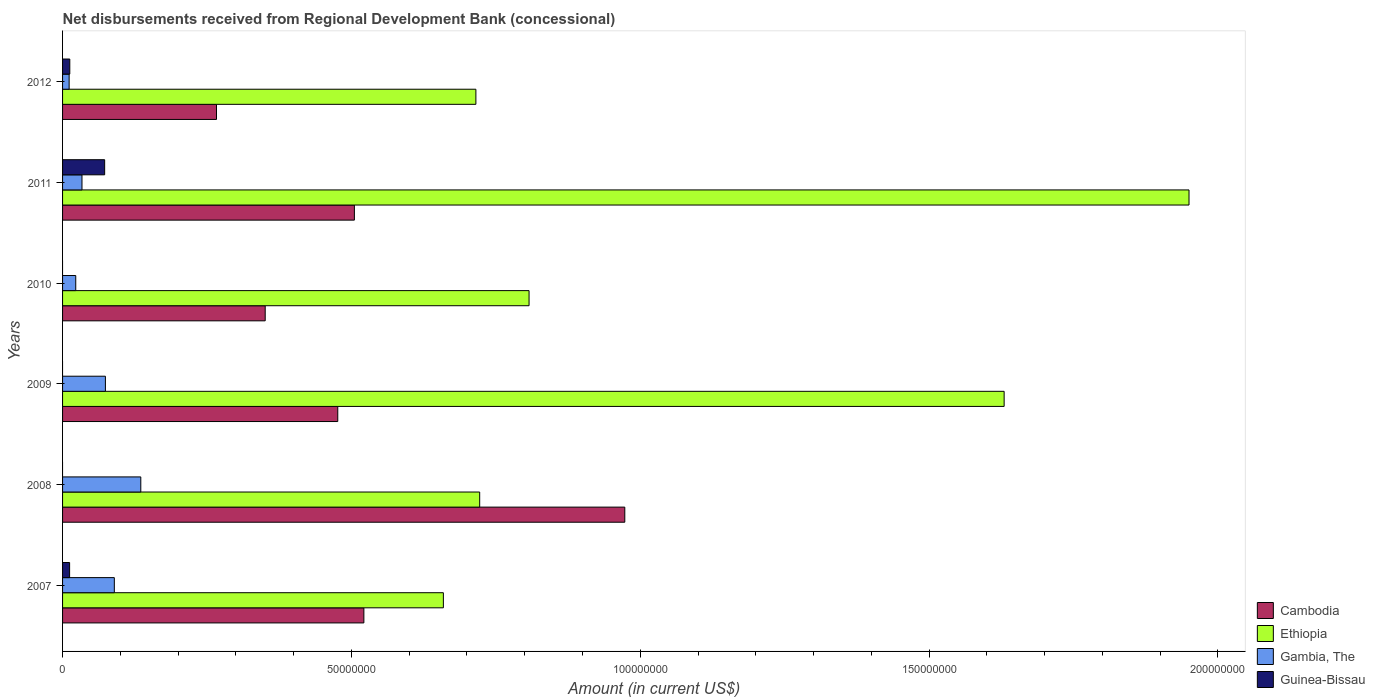Are the number of bars per tick equal to the number of legend labels?
Offer a very short reply. No. Are the number of bars on each tick of the Y-axis equal?
Ensure brevity in your answer.  No. In how many cases, is the number of bars for a given year not equal to the number of legend labels?
Your response must be concise. 3. What is the amount of disbursements received from Regional Development Bank in Ethiopia in 2007?
Your answer should be very brief. 6.59e+07. Across all years, what is the maximum amount of disbursements received from Regional Development Bank in Guinea-Bissau?
Make the answer very short. 7.28e+06. Across all years, what is the minimum amount of disbursements received from Regional Development Bank in Cambodia?
Make the answer very short. 2.66e+07. What is the total amount of disbursements received from Regional Development Bank in Gambia, The in the graph?
Your answer should be very brief. 3.67e+07. What is the difference between the amount of disbursements received from Regional Development Bank in Cambodia in 2007 and that in 2012?
Make the answer very short. 2.55e+07. What is the difference between the amount of disbursements received from Regional Development Bank in Guinea-Bissau in 2011 and the amount of disbursements received from Regional Development Bank in Cambodia in 2012?
Offer a terse response. -1.94e+07. What is the average amount of disbursements received from Regional Development Bank in Gambia, The per year?
Ensure brevity in your answer.  6.12e+06. In the year 2007, what is the difference between the amount of disbursements received from Regional Development Bank in Cambodia and amount of disbursements received from Regional Development Bank in Ethiopia?
Offer a terse response. -1.38e+07. In how many years, is the amount of disbursements received from Regional Development Bank in Ethiopia greater than 90000000 US$?
Provide a short and direct response. 2. What is the ratio of the amount of disbursements received from Regional Development Bank in Ethiopia in 2008 to that in 2010?
Ensure brevity in your answer.  0.89. Is the amount of disbursements received from Regional Development Bank in Ethiopia in 2007 less than that in 2011?
Provide a short and direct response. Yes. Is the difference between the amount of disbursements received from Regional Development Bank in Cambodia in 2007 and 2009 greater than the difference between the amount of disbursements received from Regional Development Bank in Ethiopia in 2007 and 2009?
Offer a terse response. Yes. What is the difference between the highest and the second highest amount of disbursements received from Regional Development Bank in Cambodia?
Your answer should be very brief. 4.52e+07. What is the difference between the highest and the lowest amount of disbursements received from Regional Development Bank in Ethiopia?
Make the answer very short. 1.29e+08. In how many years, is the amount of disbursements received from Regional Development Bank in Cambodia greater than the average amount of disbursements received from Regional Development Bank in Cambodia taken over all years?
Provide a succinct answer. 2. Is it the case that in every year, the sum of the amount of disbursements received from Regional Development Bank in Guinea-Bissau and amount of disbursements received from Regional Development Bank in Gambia, The is greater than the sum of amount of disbursements received from Regional Development Bank in Ethiopia and amount of disbursements received from Regional Development Bank in Cambodia?
Provide a short and direct response. No. Is it the case that in every year, the sum of the amount of disbursements received from Regional Development Bank in Gambia, The and amount of disbursements received from Regional Development Bank in Ethiopia is greater than the amount of disbursements received from Regional Development Bank in Guinea-Bissau?
Provide a succinct answer. Yes. How many bars are there?
Your answer should be very brief. 21. Are all the bars in the graph horizontal?
Your answer should be very brief. Yes. What is the difference between two consecutive major ticks on the X-axis?
Your answer should be very brief. 5.00e+07. How many legend labels are there?
Keep it short and to the point. 4. What is the title of the graph?
Your answer should be very brief. Net disbursements received from Regional Development Bank (concessional). Does "St. Martin (French part)" appear as one of the legend labels in the graph?
Offer a terse response. No. What is the Amount (in current US$) of Cambodia in 2007?
Ensure brevity in your answer.  5.22e+07. What is the Amount (in current US$) in Ethiopia in 2007?
Provide a short and direct response. 6.59e+07. What is the Amount (in current US$) in Gambia, The in 2007?
Provide a short and direct response. 8.96e+06. What is the Amount (in current US$) in Guinea-Bissau in 2007?
Provide a succinct answer. 1.22e+06. What is the Amount (in current US$) of Cambodia in 2008?
Provide a succinct answer. 9.73e+07. What is the Amount (in current US$) of Ethiopia in 2008?
Your response must be concise. 7.22e+07. What is the Amount (in current US$) in Gambia, The in 2008?
Offer a terse response. 1.35e+07. What is the Amount (in current US$) of Cambodia in 2009?
Make the answer very short. 4.76e+07. What is the Amount (in current US$) in Ethiopia in 2009?
Give a very brief answer. 1.63e+08. What is the Amount (in current US$) in Gambia, The in 2009?
Make the answer very short. 7.42e+06. What is the Amount (in current US$) of Cambodia in 2010?
Provide a succinct answer. 3.51e+07. What is the Amount (in current US$) in Ethiopia in 2010?
Give a very brief answer. 8.08e+07. What is the Amount (in current US$) in Gambia, The in 2010?
Your answer should be compact. 2.28e+06. What is the Amount (in current US$) of Cambodia in 2011?
Offer a very short reply. 5.05e+07. What is the Amount (in current US$) of Ethiopia in 2011?
Your answer should be very brief. 1.95e+08. What is the Amount (in current US$) of Gambia, The in 2011?
Give a very brief answer. 3.36e+06. What is the Amount (in current US$) of Guinea-Bissau in 2011?
Give a very brief answer. 7.28e+06. What is the Amount (in current US$) of Cambodia in 2012?
Offer a very short reply. 2.66e+07. What is the Amount (in current US$) of Ethiopia in 2012?
Ensure brevity in your answer.  7.15e+07. What is the Amount (in current US$) of Gambia, The in 2012?
Offer a very short reply. 1.14e+06. What is the Amount (in current US$) of Guinea-Bissau in 2012?
Ensure brevity in your answer.  1.25e+06. Across all years, what is the maximum Amount (in current US$) in Cambodia?
Your answer should be very brief. 9.73e+07. Across all years, what is the maximum Amount (in current US$) in Ethiopia?
Provide a short and direct response. 1.95e+08. Across all years, what is the maximum Amount (in current US$) of Gambia, The?
Provide a short and direct response. 1.35e+07. Across all years, what is the maximum Amount (in current US$) in Guinea-Bissau?
Your response must be concise. 7.28e+06. Across all years, what is the minimum Amount (in current US$) of Cambodia?
Ensure brevity in your answer.  2.66e+07. Across all years, what is the minimum Amount (in current US$) of Ethiopia?
Your response must be concise. 6.59e+07. Across all years, what is the minimum Amount (in current US$) of Gambia, The?
Give a very brief answer. 1.14e+06. What is the total Amount (in current US$) in Cambodia in the graph?
Your answer should be compact. 3.09e+08. What is the total Amount (in current US$) of Ethiopia in the graph?
Make the answer very short. 6.48e+08. What is the total Amount (in current US$) in Gambia, The in the graph?
Your answer should be very brief. 3.67e+07. What is the total Amount (in current US$) in Guinea-Bissau in the graph?
Offer a terse response. 9.76e+06. What is the difference between the Amount (in current US$) in Cambodia in 2007 and that in 2008?
Your answer should be very brief. -4.52e+07. What is the difference between the Amount (in current US$) in Ethiopia in 2007 and that in 2008?
Ensure brevity in your answer.  -6.29e+06. What is the difference between the Amount (in current US$) of Gambia, The in 2007 and that in 2008?
Give a very brief answer. -4.58e+06. What is the difference between the Amount (in current US$) of Cambodia in 2007 and that in 2009?
Your answer should be very brief. 4.52e+06. What is the difference between the Amount (in current US$) in Ethiopia in 2007 and that in 2009?
Your response must be concise. -9.71e+07. What is the difference between the Amount (in current US$) of Gambia, The in 2007 and that in 2009?
Offer a terse response. 1.55e+06. What is the difference between the Amount (in current US$) in Cambodia in 2007 and that in 2010?
Your response must be concise. 1.71e+07. What is the difference between the Amount (in current US$) in Ethiopia in 2007 and that in 2010?
Your answer should be very brief. -1.48e+07. What is the difference between the Amount (in current US$) in Gambia, The in 2007 and that in 2010?
Ensure brevity in your answer.  6.68e+06. What is the difference between the Amount (in current US$) in Cambodia in 2007 and that in 2011?
Offer a very short reply. 1.64e+06. What is the difference between the Amount (in current US$) in Ethiopia in 2007 and that in 2011?
Make the answer very short. -1.29e+08. What is the difference between the Amount (in current US$) in Gambia, The in 2007 and that in 2011?
Your response must be concise. 5.60e+06. What is the difference between the Amount (in current US$) of Guinea-Bissau in 2007 and that in 2011?
Give a very brief answer. -6.06e+06. What is the difference between the Amount (in current US$) of Cambodia in 2007 and that in 2012?
Your answer should be very brief. 2.55e+07. What is the difference between the Amount (in current US$) in Ethiopia in 2007 and that in 2012?
Make the answer very short. -5.63e+06. What is the difference between the Amount (in current US$) of Gambia, The in 2007 and that in 2012?
Your response must be concise. 7.82e+06. What is the difference between the Amount (in current US$) of Guinea-Bissau in 2007 and that in 2012?
Your answer should be very brief. -3.20e+04. What is the difference between the Amount (in current US$) in Cambodia in 2008 and that in 2009?
Ensure brevity in your answer.  4.97e+07. What is the difference between the Amount (in current US$) in Ethiopia in 2008 and that in 2009?
Give a very brief answer. -9.08e+07. What is the difference between the Amount (in current US$) in Gambia, The in 2008 and that in 2009?
Your response must be concise. 6.13e+06. What is the difference between the Amount (in current US$) in Cambodia in 2008 and that in 2010?
Your response must be concise. 6.22e+07. What is the difference between the Amount (in current US$) in Ethiopia in 2008 and that in 2010?
Your answer should be very brief. -8.55e+06. What is the difference between the Amount (in current US$) in Gambia, The in 2008 and that in 2010?
Keep it short and to the point. 1.13e+07. What is the difference between the Amount (in current US$) of Cambodia in 2008 and that in 2011?
Provide a succinct answer. 4.68e+07. What is the difference between the Amount (in current US$) in Ethiopia in 2008 and that in 2011?
Offer a terse response. -1.23e+08. What is the difference between the Amount (in current US$) in Gambia, The in 2008 and that in 2011?
Your answer should be very brief. 1.02e+07. What is the difference between the Amount (in current US$) of Cambodia in 2008 and that in 2012?
Your response must be concise. 7.07e+07. What is the difference between the Amount (in current US$) in Ethiopia in 2008 and that in 2012?
Your answer should be compact. 6.56e+05. What is the difference between the Amount (in current US$) in Gambia, The in 2008 and that in 2012?
Ensure brevity in your answer.  1.24e+07. What is the difference between the Amount (in current US$) in Cambodia in 2009 and that in 2010?
Offer a very short reply. 1.26e+07. What is the difference between the Amount (in current US$) in Ethiopia in 2009 and that in 2010?
Provide a succinct answer. 8.22e+07. What is the difference between the Amount (in current US$) of Gambia, The in 2009 and that in 2010?
Your response must be concise. 5.13e+06. What is the difference between the Amount (in current US$) of Cambodia in 2009 and that in 2011?
Give a very brief answer. -2.88e+06. What is the difference between the Amount (in current US$) of Ethiopia in 2009 and that in 2011?
Provide a succinct answer. -3.20e+07. What is the difference between the Amount (in current US$) of Gambia, The in 2009 and that in 2011?
Offer a terse response. 4.05e+06. What is the difference between the Amount (in current US$) in Cambodia in 2009 and that in 2012?
Offer a very short reply. 2.10e+07. What is the difference between the Amount (in current US$) of Ethiopia in 2009 and that in 2012?
Ensure brevity in your answer.  9.14e+07. What is the difference between the Amount (in current US$) of Gambia, The in 2009 and that in 2012?
Keep it short and to the point. 6.28e+06. What is the difference between the Amount (in current US$) of Cambodia in 2010 and that in 2011?
Make the answer very short. -1.54e+07. What is the difference between the Amount (in current US$) of Ethiopia in 2010 and that in 2011?
Make the answer very short. -1.14e+08. What is the difference between the Amount (in current US$) of Gambia, The in 2010 and that in 2011?
Your answer should be compact. -1.08e+06. What is the difference between the Amount (in current US$) in Cambodia in 2010 and that in 2012?
Provide a succinct answer. 8.43e+06. What is the difference between the Amount (in current US$) in Ethiopia in 2010 and that in 2012?
Ensure brevity in your answer.  9.20e+06. What is the difference between the Amount (in current US$) in Gambia, The in 2010 and that in 2012?
Make the answer very short. 1.15e+06. What is the difference between the Amount (in current US$) in Cambodia in 2011 and that in 2012?
Your response must be concise. 2.39e+07. What is the difference between the Amount (in current US$) of Ethiopia in 2011 and that in 2012?
Keep it short and to the point. 1.23e+08. What is the difference between the Amount (in current US$) of Gambia, The in 2011 and that in 2012?
Offer a very short reply. 2.22e+06. What is the difference between the Amount (in current US$) of Guinea-Bissau in 2011 and that in 2012?
Offer a very short reply. 6.03e+06. What is the difference between the Amount (in current US$) in Cambodia in 2007 and the Amount (in current US$) in Ethiopia in 2008?
Offer a terse response. -2.00e+07. What is the difference between the Amount (in current US$) in Cambodia in 2007 and the Amount (in current US$) in Gambia, The in 2008?
Offer a terse response. 3.86e+07. What is the difference between the Amount (in current US$) of Ethiopia in 2007 and the Amount (in current US$) of Gambia, The in 2008?
Offer a very short reply. 5.24e+07. What is the difference between the Amount (in current US$) in Cambodia in 2007 and the Amount (in current US$) in Ethiopia in 2009?
Offer a very short reply. -1.11e+08. What is the difference between the Amount (in current US$) of Cambodia in 2007 and the Amount (in current US$) of Gambia, The in 2009?
Ensure brevity in your answer.  4.47e+07. What is the difference between the Amount (in current US$) of Ethiopia in 2007 and the Amount (in current US$) of Gambia, The in 2009?
Ensure brevity in your answer.  5.85e+07. What is the difference between the Amount (in current US$) in Cambodia in 2007 and the Amount (in current US$) in Ethiopia in 2010?
Provide a succinct answer. -2.86e+07. What is the difference between the Amount (in current US$) in Cambodia in 2007 and the Amount (in current US$) in Gambia, The in 2010?
Provide a succinct answer. 4.99e+07. What is the difference between the Amount (in current US$) in Ethiopia in 2007 and the Amount (in current US$) in Gambia, The in 2010?
Keep it short and to the point. 6.36e+07. What is the difference between the Amount (in current US$) in Cambodia in 2007 and the Amount (in current US$) in Ethiopia in 2011?
Provide a succinct answer. -1.43e+08. What is the difference between the Amount (in current US$) of Cambodia in 2007 and the Amount (in current US$) of Gambia, The in 2011?
Make the answer very short. 4.88e+07. What is the difference between the Amount (in current US$) in Cambodia in 2007 and the Amount (in current US$) in Guinea-Bissau in 2011?
Offer a very short reply. 4.49e+07. What is the difference between the Amount (in current US$) in Ethiopia in 2007 and the Amount (in current US$) in Gambia, The in 2011?
Provide a short and direct response. 6.26e+07. What is the difference between the Amount (in current US$) of Ethiopia in 2007 and the Amount (in current US$) of Guinea-Bissau in 2011?
Provide a succinct answer. 5.86e+07. What is the difference between the Amount (in current US$) of Gambia, The in 2007 and the Amount (in current US$) of Guinea-Bissau in 2011?
Your response must be concise. 1.68e+06. What is the difference between the Amount (in current US$) in Cambodia in 2007 and the Amount (in current US$) in Ethiopia in 2012?
Your answer should be very brief. -1.94e+07. What is the difference between the Amount (in current US$) of Cambodia in 2007 and the Amount (in current US$) of Gambia, The in 2012?
Ensure brevity in your answer.  5.10e+07. What is the difference between the Amount (in current US$) in Cambodia in 2007 and the Amount (in current US$) in Guinea-Bissau in 2012?
Provide a succinct answer. 5.09e+07. What is the difference between the Amount (in current US$) of Ethiopia in 2007 and the Amount (in current US$) of Gambia, The in 2012?
Ensure brevity in your answer.  6.48e+07. What is the difference between the Amount (in current US$) of Ethiopia in 2007 and the Amount (in current US$) of Guinea-Bissau in 2012?
Your answer should be very brief. 6.47e+07. What is the difference between the Amount (in current US$) of Gambia, The in 2007 and the Amount (in current US$) of Guinea-Bissau in 2012?
Your answer should be compact. 7.71e+06. What is the difference between the Amount (in current US$) of Cambodia in 2008 and the Amount (in current US$) of Ethiopia in 2009?
Give a very brief answer. -6.57e+07. What is the difference between the Amount (in current US$) in Cambodia in 2008 and the Amount (in current US$) in Gambia, The in 2009?
Offer a very short reply. 8.99e+07. What is the difference between the Amount (in current US$) of Ethiopia in 2008 and the Amount (in current US$) of Gambia, The in 2009?
Your answer should be compact. 6.48e+07. What is the difference between the Amount (in current US$) of Cambodia in 2008 and the Amount (in current US$) of Ethiopia in 2010?
Ensure brevity in your answer.  1.66e+07. What is the difference between the Amount (in current US$) of Cambodia in 2008 and the Amount (in current US$) of Gambia, The in 2010?
Provide a succinct answer. 9.50e+07. What is the difference between the Amount (in current US$) in Ethiopia in 2008 and the Amount (in current US$) in Gambia, The in 2010?
Keep it short and to the point. 6.99e+07. What is the difference between the Amount (in current US$) in Cambodia in 2008 and the Amount (in current US$) in Ethiopia in 2011?
Your response must be concise. -9.77e+07. What is the difference between the Amount (in current US$) in Cambodia in 2008 and the Amount (in current US$) in Gambia, The in 2011?
Make the answer very short. 9.40e+07. What is the difference between the Amount (in current US$) in Cambodia in 2008 and the Amount (in current US$) in Guinea-Bissau in 2011?
Your answer should be compact. 9.00e+07. What is the difference between the Amount (in current US$) of Ethiopia in 2008 and the Amount (in current US$) of Gambia, The in 2011?
Provide a succinct answer. 6.88e+07. What is the difference between the Amount (in current US$) of Ethiopia in 2008 and the Amount (in current US$) of Guinea-Bissau in 2011?
Make the answer very short. 6.49e+07. What is the difference between the Amount (in current US$) in Gambia, The in 2008 and the Amount (in current US$) in Guinea-Bissau in 2011?
Your answer should be very brief. 6.26e+06. What is the difference between the Amount (in current US$) of Cambodia in 2008 and the Amount (in current US$) of Ethiopia in 2012?
Provide a succinct answer. 2.58e+07. What is the difference between the Amount (in current US$) in Cambodia in 2008 and the Amount (in current US$) in Gambia, The in 2012?
Provide a short and direct response. 9.62e+07. What is the difference between the Amount (in current US$) of Cambodia in 2008 and the Amount (in current US$) of Guinea-Bissau in 2012?
Keep it short and to the point. 9.61e+07. What is the difference between the Amount (in current US$) in Ethiopia in 2008 and the Amount (in current US$) in Gambia, The in 2012?
Provide a short and direct response. 7.11e+07. What is the difference between the Amount (in current US$) in Ethiopia in 2008 and the Amount (in current US$) in Guinea-Bissau in 2012?
Offer a very short reply. 7.10e+07. What is the difference between the Amount (in current US$) in Gambia, The in 2008 and the Amount (in current US$) in Guinea-Bissau in 2012?
Offer a very short reply. 1.23e+07. What is the difference between the Amount (in current US$) of Cambodia in 2009 and the Amount (in current US$) of Ethiopia in 2010?
Provide a short and direct response. -3.31e+07. What is the difference between the Amount (in current US$) of Cambodia in 2009 and the Amount (in current US$) of Gambia, The in 2010?
Give a very brief answer. 4.54e+07. What is the difference between the Amount (in current US$) of Ethiopia in 2009 and the Amount (in current US$) of Gambia, The in 2010?
Your answer should be compact. 1.61e+08. What is the difference between the Amount (in current US$) in Cambodia in 2009 and the Amount (in current US$) in Ethiopia in 2011?
Your answer should be very brief. -1.47e+08. What is the difference between the Amount (in current US$) in Cambodia in 2009 and the Amount (in current US$) in Gambia, The in 2011?
Ensure brevity in your answer.  4.43e+07. What is the difference between the Amount (in current US$) of Cambodia in 2009 and the Amount (in current US$) of Guinea-Bissau in 2011?
Make the answer very short. 4.04e+07. What is the difference between the Amount (in current US$) of Ethiopia in 2009 and the Amount (in current US$) of Gambia, The in 2011?
Give a very brief answer. 1.60e+08. What is the difference between the Amount (in current US$) of Ethiopia in 2009 and the Amount (in current US$) of Guinea-Bissau in 2011?
Give a very brief answer. 1.56e+08. What is the difference between the Amount (in current US$) of Gambia, The in 2009 and the Amount (in current US$) of Guinea-Bissau in 2011?
Your answer should be compact. 1.30e+05. What is the difference between the Amount (in current US$) in Cambodia in 2009 and the Amount (in current US$) in Ethiopia in 2012?
Make the answer very short. -2.39e+07. What is the difference between the Amount (in current US$) of Cambodia in 2009 and the Amount (in current US$) of Gambia, The in 2012?
Your response must be concise. 4.65e+07. What is the difference between the Amount (in current US$) in Cambodia in 2009 and the Amount (in current US$) in Guinea-Bissau in 2012?
Your response must be concise. 4.64e+07. What is the difference between the Amount (in current US$) of Ethiopia in 2009 and the Amount (in current US$) of Gambia, The in 2012?
Make the answer very short. 1.62e+08. What is the difference between the Amount (in current US$) in Ethiopia in 2009 and the Amount (in current US$) in Guinea-Bissau in 2012?
Your response must be concise. 1.62e+08. What is the difference between the Amount (in current US$) of Gambia, The in 2009 and the Amount (in current US$) of Guinea-Bissau in 2012?
Your answer should be compact. 6.16e+06. What is the difference between the Amount (in current US$) in Cambodia in 2010 and the Amount (in current US$) in Ethiopia in 2011?
Your answer should be compact. -1.60e+08. What is the difference between the Amount (in current US$) in Cambodia in 2010 and the Amount (in current US$) in Gambia, The in 2011?
Offer a terse response. 3.17e+07. What is the difference between the Amount (in current US$) in Cambodia in 2010 and the Amount (in current US$) in Guinea-Bissau in 2011?
Ensure brevity in your answer.  2.78e+07. What is the difference between the Amount (in current US$) of Ethiopia in 2010 and the Amount (in current US$) of Gambia, The in 2011?
Your response must be concise. 7.74e+07. What is the difference between the Amount (in current US$) of Ethiopia in 2010 and the Amount (in current US$) of Guinea-Bissau in 2011?
Your answer should be compact. 7.35e+07. What is the difference between the Amount (in current US$) of Gambia, The in 2010 and the Amount (in current US$) of Guinea-Bissau in 2011?
Make the answer very short. -5.00e+06. What is the difference between the Amount (in current US$) in Cambodia in 2010 and the Amount (in current US$) in Ethiopia in 2012?
Offer a terse response. -3.65e+07. What is the difference between the Amount (in current US$) of Cambodia in 2010 and the Amount (in current US$) of Gambia, The in 2012?
Ensure brevity in your answer.  3.39e+07. What is the difference between the Amount (in current US$) of Cambodia in 2010 and the Amount (in current US$) of Guinea-Bissau in 2012?
Offer a terse response. 3.38e+07. What is the difference between the Amount (in current US$) of Ethiopia in 2010 and the Amount (in current US$) of Gambia, The in 2012?
Ensure brevity in your answer.  7.96e+07. What is the difference between the Amount (in current US$) in Ethiopia in 2010 and the Amount (in current US$) in Guinea-Bissau in 2012?
Make the answer very short. 7.95e+07. What is the difference between the Amount (in current US$) of Gambia, The in 2010 and the Amount (in current US$) of Guinea-Bissau in 2012?
Ensure brevity in your answer.  1.03e+06. What is the difference between the Amount (in current US$) of Cambodia in 2011 and the Amount (in current US$) of Ethiopia in 2012?
Provide a succinct answer. -2.10e+07. What is the difference between the Amount (in current US$) of Cambodia in 2011 and the Amount (in current US$) of Gambia, The in 2012?
Offer a very short reply. 4.94e+07. What is the difference between the Amount (in current US$) of Cambodia in 2011 and the Amount (in current US$) of Guinea-Bissau in 2012?
Offer a very short reply. 4.93e+07. What is the difference between the Amount (in current US$) in Ethiopia in 2011 and the Amount (in current US$) in Gambia, The in 2012?
Your answer should be compact. 1.94e+08. What is the difference between the Amount (in current US$) of Ethiopia in 2011 and the Amount (in current US$) of Guinea-Bissau in 2012?
Offer a very short reply. 1.94e+08. What is the difference between the Amount (in current US$) in Gambia, The in 2011 and the Amount (in current US$) in Guinea-Bissau in 2012?
Ensure brevity in your answer.  2.11e+06. What is the average Amount (in current US$) in Cambodia per year?
Make the answer very short. 5.16e+07. What is the average Amount (in current US$) of Ethiopia per year?
Keep it short and to the point. 1.08e+08. What is the average Amount (in current US$) of Gambia, The per year?
Make the answer very short. 6.12e+06. What is the average Amount (in current US$) in Guinea-Bissau per year?
Ensure brevity in your answer.  1.63e+06. In the year 2007, what is the difference between the Amount (in current US$) of Cambodia and Amount (in current US$) of Ethiopia?
Provide a succinct answer. -1.38e+07. In the year 2007, what is the difference between the Amount (in current US$) in Cambodia and Amount (in current US$) in Gambia, The?
Give a very brief answer. 4.32e+07. In the year 2007, what is the difference between the Amount (in current US$) in Cambodia and Amount (in current US$) in Guinea-Bissau?
Provide a succinct answer. 5.09e+07. In the year 2007, what is the difference between the Amount (in current US$) of Ethiopia and Amount (in current US$) of Gambia, The?
Your response must be concise. 5.70e+07. In the year 2007, what is the difference between the Amount (in current US$) in Ethiopia and Amount (in current US$) in Guinea-Bissau?
Give a very brief answer. 6.47e+07. In the year 2007, what is the difference between the Amount (in current US$) of Gambia, The and Amount (in current US$) of Guinea-Bissau?
Keep it short and to the point. 7.74e+06. In the year 2008, what is the difference between the Amount (in current US$) in Cambodia and Amount (in current US$) in Ethiopia?
Provide a succinct answer. 2.51e+07. In the year 2008, what is the difference between the Amount (in current US$) in Cambodia and Amount (in current US$) in Gambia, The?
Make the answer very short. 8.38e+07. In the year 2008, what is the difference between the Amount (in current US$) in Ethiopia and Amount (in current US$) in Gambia, The?
Ensure brevity in your answer.  5.87e+07. In the year 2009, what is the difference between the Amount (in current US$) in Cambodia and Amount (in current US$) in Ethiopia?
Make the answer very short. -1.15e+08. In the year 2009, what is the difference between the Amount (in current US$) of Cambodia and Amount (in current US$) of Gambia, The?
Offer a terse response. 4.02e+07. In the year 2009, what is the difference between the Amount (in current US$) of Ethiopia and Amount (in current US$) of Gambia, The?
Provide a succinct answer. 1.56e+08. In the year 2010, what is the difference between the Amount (in current US$) of Cambodia and Amount (in current US$) of Ethiopia?
Offer a very short reply. -4.57e+07. In the year 2010, what is the difference between the Amount (in current US$) of Cambodia and Amount (in current US$) of Gambia, The?
Make the answer very short. 3.28e+07. In the year 2010, what is the difference between the Amount (in current US$) of Ethiopia and Amount (in current US$) of Gambia, The?
Offer a terse response. 7.85e+07. In the year 2011, what is the difference between the Amount (in current US$) in Cambodia and Amount (in current US$) in Ethiopia?
Provide a short and direct response. -1.44e+08. In the year 2011, what is the difference between the Amount (in current US$) of Cambodia and Amount (in current US$) of Gambia, The?
Ensure brevity in your answer.  4.72e+07. In the year 2011, what is the difference between the Amount (in current US$) in Cambodia and Amount (in current US$) in Guinea-Bissau?
Make the answer very short. 4.32e+07. In the year 2011, what is the difference between the Amount (in current US$) of Ethiopia and Amount (in current US$) of Gambia, The?
Provide a succinct answer. 1.92e+08. In the year 2011, what is the difference between the Amount (in current US$) in Ethiopia and Amount (in current US$) in Guinea-Bissau?
Offer a very short reply. 1.88e+08. In the year 2011, what is the difference between the Amount (in current US$) of Gambia, The and Amount (in current US$) of Guinea-Bissau?
Make the answer very short. -3.92e+06. In the year 2012, what is the difference between the Amount (in current US$) of Cambodia and Amount (in current US$) of Ethiopia?
Give a very brief answer. -4.49e+07. In the year 2012, what is the difference between the Amount (in current US$) in Cambodia and Amount (in current US$) in Gambia, The?
Provide a short and direct response. 2.55e+07. In the year 2012, what is the difference between the Amount (in current US$) in Cambodia and Amount (in current US$) in Guinea-Bissau?
Your response must be concise. 2.54e+07. In the year 2012, what is the difference between the Amount (in current US$) in Ethiopia and Amount (in current US$) in Gambia, The?
Ensure brevity in your answer.  7.04e+07. In the year 2012, what is the difference between the Amount (in current US$) in Ethiopia and Amount (in current US$) in Guinea-Bissau?
Make the answer very short. 7.03e+07. In the year 2012, what is the difference between the Amount (in current US$) of Gambia, The and Amount (in current US$) of Guinea-Bissau?
Offer a very short reply. -1.15e+05. What is the ratio of the Amount (in current US$) of Cambodia in 2007 to that in 2008?
Your response must be concise. 0.54. What is the ratio of the Amount (in current US$) in Ethiopia in 2007 to that in 2008?
Ensure brevity in your answer.  0.91. What is the ratio of the Amount (in current US$) in Gambia, The in 2007 to that in 2008?
Offer a terse response. 0.66. What is the ratio of the Amount (in current US$) of Cambodia in 2007 to that in 2009?
Provide a short and direct response. 1.09. What is the ratio of the Amount (in current US$) in Ethiopia in 2007 to that in 2009?
Your response must be concise. 0.4. What is the ratio of the Amount (in current US$) in Gambia, The in 2007 to that in 2009?
Your response must be concise. 1.21. What is the ratio of the Amount (in current US$) in Cambodia in 2007 to that in 2010?
Ensure brevity in your answer.  1.49. What is the ratio of the Amount (in current US$) of Ethiopia in 2007 to that in 2010?
Your answer should be very brief. 0.82. What is the ratio of the Amount (in current US$) of Gambia, The in 2007 to that in 2010?
Keep it short and to the point. 3.93. What is the ratio of the Amount (in current US$) in Cambodia in 2007 to that in 2011?
Make the answer very short. 1.03. What is the ratio of the Amount (in current US$) in Ethiopia in 2007 to that in 2011?
Your response must be concise. 0.34. What is the ratio of the Amount (in current US$) in Gambia, The in 2007 to that in 2011?
Offer a very short reply. 2.67. What is the ratio of the Amount (in current US$) in Guinea-Bissau in 2007 to that in 2011?
Your response must be concise. 0.17. What is the ratio of the Amount (in current US$) of Cambodia in 2007 to that in 2012?
Offer a terse response. 1.96. What is the ratio of the Amount (in current US$) in Ethiopia in 2007 to that in 2012?
Provide a short and direct response. 0.92. What is the ratio of the Amount (in current US$) in Gambia, The in 2007 to that in 2012?
Your response must be concise. 7.88. What is the ratio of the Amount (in current US$) of Guinea-Bissau in 2007 to that in 2012?
Give a very brief answer. 0.97. What is the ratio of the Amount (in current US$) in Cambodia in 2008 to that in 2009?
Your answer should be very brief. 2.04. What is the ratio of the Amount (in current US$) in Ethiopia in 2008 to that in 2009?
Offer a very short reply. 0.44. What is the ratio of the Amount (in current US$) of Gambia, The in 2008 to that in 2009?
Your answer should be very brief. 1.83. What is the ratio of the Amount (in current US$) of Cambodia in 2008 to that in 2010?
Ensure brevity in your answer.  2.77. What is the ratio of the Amount (in current US$) of Ethiopia in 2008 to that in 2010?
Ensure brevity in your answer.  0.89. What is the ratio of the Amount (in current US$) in Gambia, The in 2008 to that in 2010?
Give a very brief answer. 5.93. What is the ratio of the Amount (in current US$) of Cambodia in 2008 to that in 2011?
Offer a very short reply. 1.93. What is the ratio of the Amount (in current US$) in Ethiopia in 2008 to that in 2011?
Offer a very short reply. 0.37. What is the ratio of the Amount (in current US$) in Gambia, The in 2008 to that in 2011?
Your answer should be very brief. 4.03. What is the ratio of the Amount (in current US$) in Cambodia in 2008 to that in 2012?
Provide a short and direct response. 3.65. What is the ratio of the Amount (in current US$) in Ethiopia in 2008 to that in 2012?
Provide a short and direct response. 1.01. What is the ratio of the Amount (in current US$) of Gambia, The in 2008 to that in 2012?
Your response must be concise. 11.91. What is the ratio of the Amount (in current US$) of Cambodia in 2009 to that in 2010?
Give a very brief answer. 1.36. What is the ratio of the Amount (in current US$) of Ethiopia in 2009 to that in 2010?
Your response must be concise. 2.02. What is the ratio of the Amount (in current US$) of Gambia, The in 2009 to that in 2010?
Provide a succinct answer. 3.25. What is the ratio of the Amount (in current US$) of Cambodia in 2009 to that in 2011?
Your answer should be very brief. 0.94. What is the ratio of the Amount (in current US$) of Ethiopia in 2009 to that in 2011?
Offer a terse response. 0.84. What is the ratio of the Amount (in current US$) of Gambia, The in 2009 to that in 2011?
Keep it short and to the point. 2.21. What is the ratio of the Amount (in current US$) in Cambodia in 2009 to that in 2012?
Your answer should be very brief. 1.79. What is the ratio of the Amount (in current US$) of Ethiopia in 2009 to that in 2012?
Your answer should be compact. 2.28. What is the ratio of the Amount (in current US$) in Gambia, The in 2009 to that in 2012?
Your response must be concise. 6.52. What is the ratio of the Amount (in current US$) of Cambodia in 2010 to that in 2011?
Your answer should be very brief. 0.69. What is the ratio of the Amount (in current US$) in Ethiopia in 2010 to that in 2011?
Provide a short and direct response. 0.41. What is the ratio of the Amount (in current US$) of Gambia, The in 2010 to that in 2011?
Ensure brevity in your answer.  0.68. What is the ratio of the Amount (in current US$) of Cambodia in 2010 to that in 2012?
Keep it short and to the point. 1.32. What is the ratio of the Amount (in current US$) in Ethiopia in 2010 to that in 2012?
Make the answer very short. 1.13. What is the ratio of the Amount (in current US$) of Gambia, The in 2010 to that in 2012?
Provide a succinct answer. 2.01. What is the ratio of the Amount (in current US$) of Cambodia in 2011 to that in 2012?
Keep it short and to the point. 1.9. What is the ratio of the Amount (in current US$) of Ethiopia in 2011 to that in 2012?
Give a very brief answer. 2.73. What is the ratio of the Amount (in current US$) in Gambia, The in 2011 to that in 2012?
Offer a terse response. 2.96. What is the ratio of the Amount (in current US$) of Guinea-Bissau in 2011 to that in 2012?
Make the answer very short. 5.82. What is the difference between the highest and the second highest Amount (in current US$) in Cambodia?
Keep it short and to the point. 4.52e+07. What is the difference between the highest and the second highest Amount (in current US$) in Ethiopia?
Your answer should be very brief. 3.20e+07. What is the difference between the highest and the second highest Amount (in current US$) in Gambia, The?
Your response must be concise. 4.58e+06. What is the difference between the highest and the second highest Amount (in current US$) of Guinea-Bissau?
Provide a short and direct response. 6.03e+06. What is the difference between the highest and the lowest Amount (in current US$) in Cambodia?
Your response must be concise. 7.07e+07. What is the difference between the highest and the lowest Amount (in current US$) in Ethiopia?
Give a very brief answer. 1.29e+08. What is the difference between the highest and the lowest Amount (in current US$) of Gambia, The?
Your answer should be compact. 1.24e+07. What is the difference between the highest and the lowest Amount (in current US$) in Guinea-Bissau?
Provide a short and direct response. 7.28e+06. 